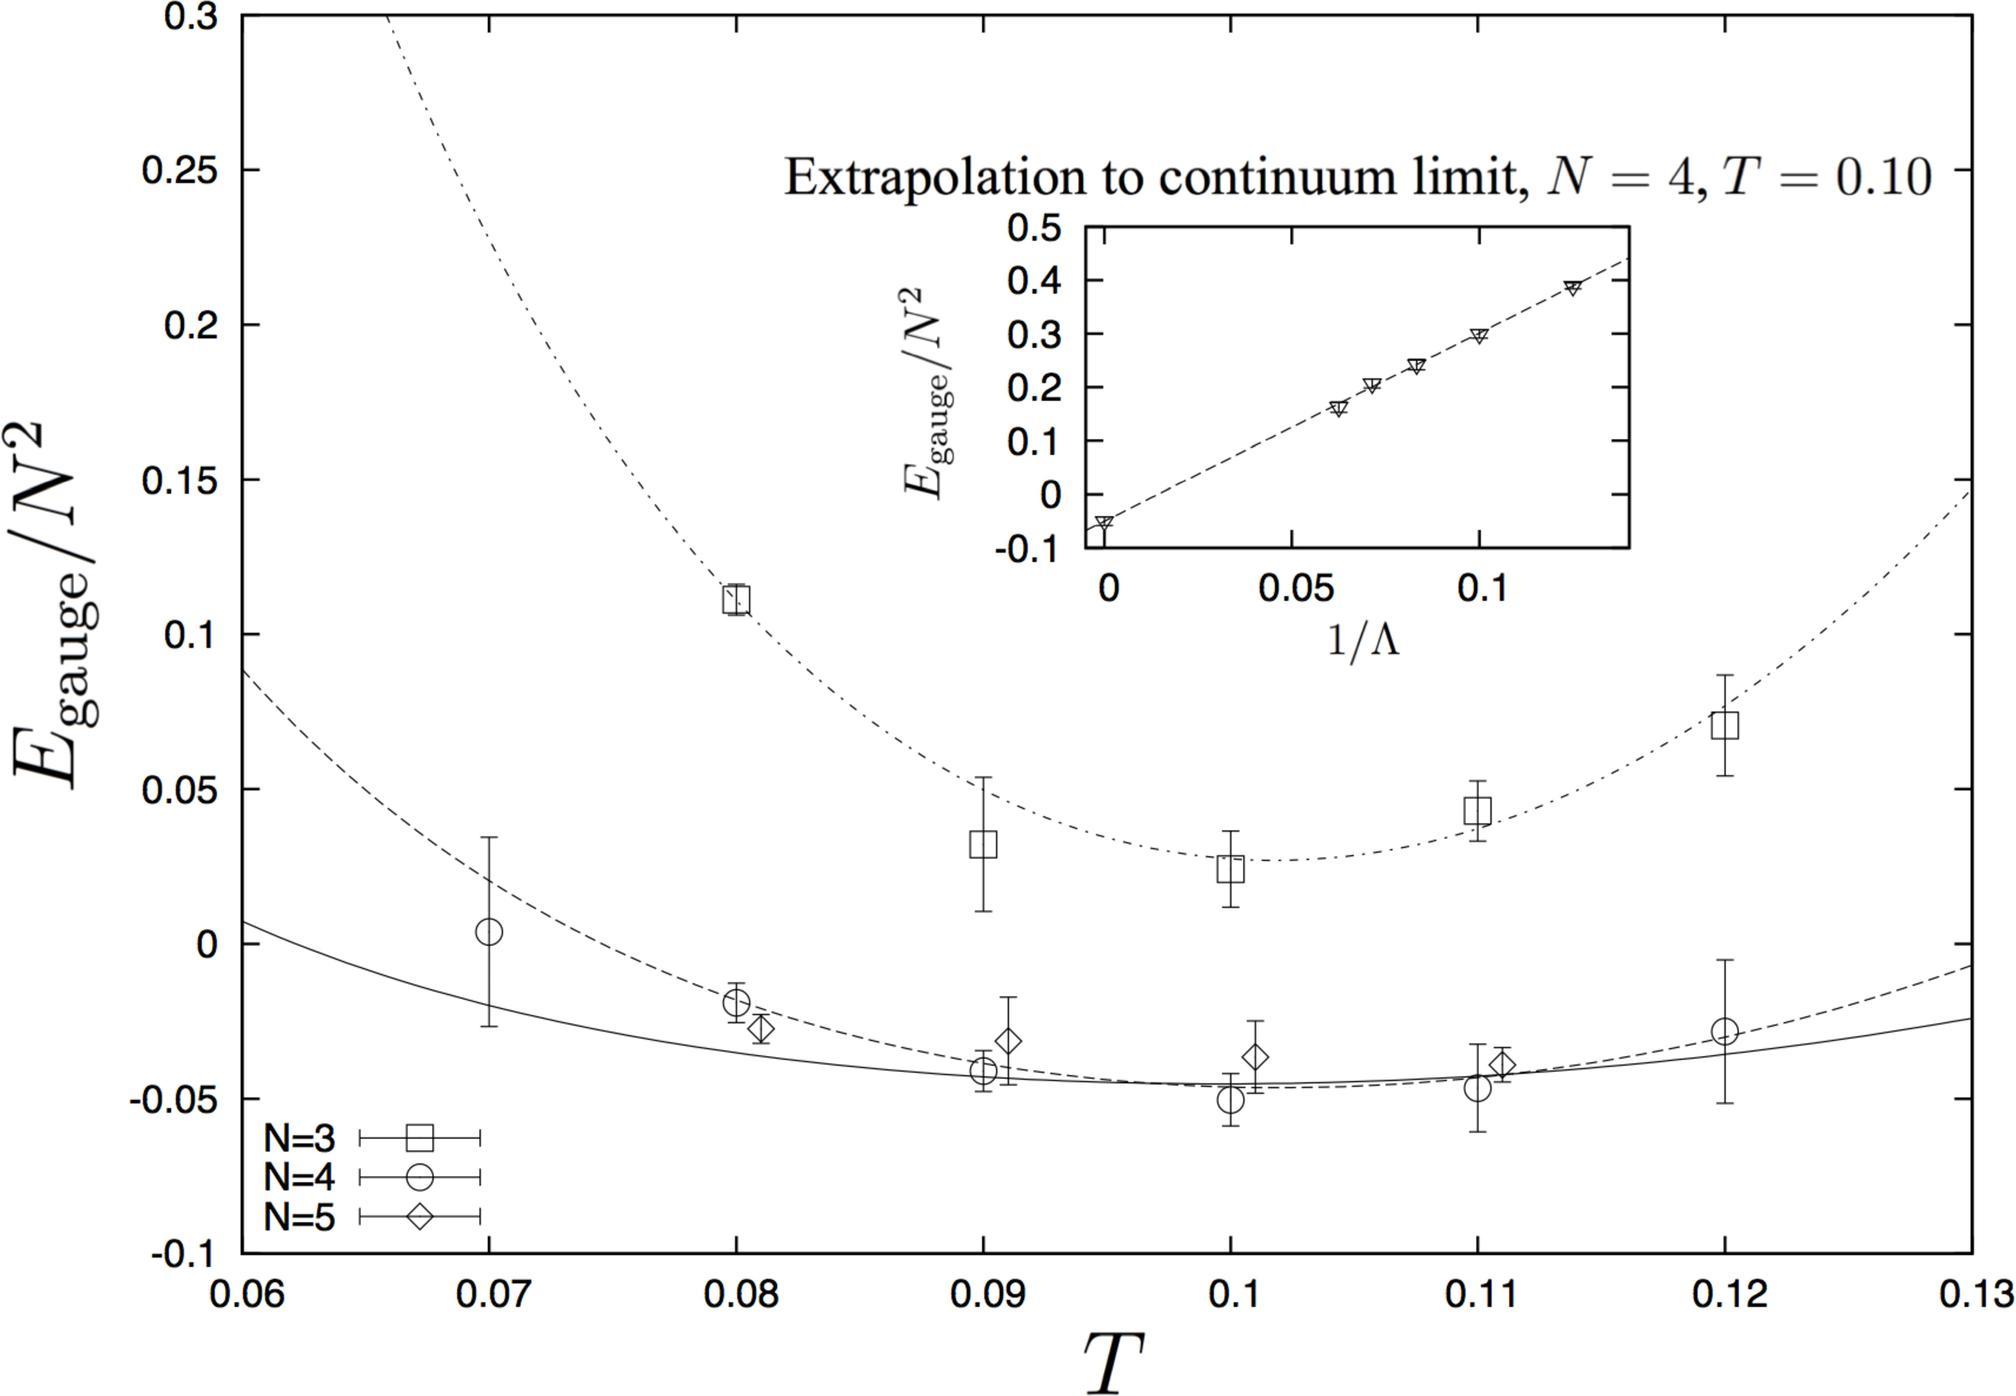Why does the graph show both solid and dashed lines? The graph shows solid and dashed lines to distinguish between actual measured data points and theoretical predictions or fits respectively. Solid lines might represent empirical data obtained through experiments or simulations, while dashed lines likely indicate theoretical model predictions or extrapolations based on the empirical data. This distinction helps in visual analysis and theoretical verification. 